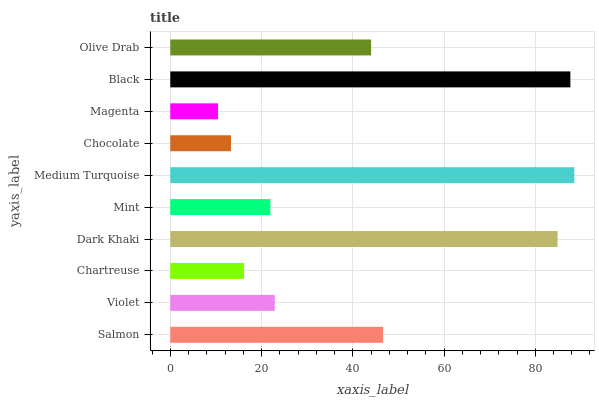Is Magenta the minimum?
Answer yes or no. Yes. Is Medium Turquoise the maximum?
Answer yes or no. Yes. Is Violet the minimum?
Answer yes or no. No. Is Violet the maximum?
Answer yes or no. No. Is Salmon greater than Violet?
Answer yes or no. Yes. Is Violet less than Salmon?
Answer yes or no. Yes. Is Violet greater than Salmon?
Answer yes or no. No. Is Salmon less than Violet?
Answer yes or no. No. Is Olive Drab the high median?
Answer yes or no. Yes. Is Violet the low median?
Answer yes or no. Yes. Is Dark Khaki the high median?
Answer yes or no. No. Is Dark Khaki the low median?
Answer yes or no. No. 